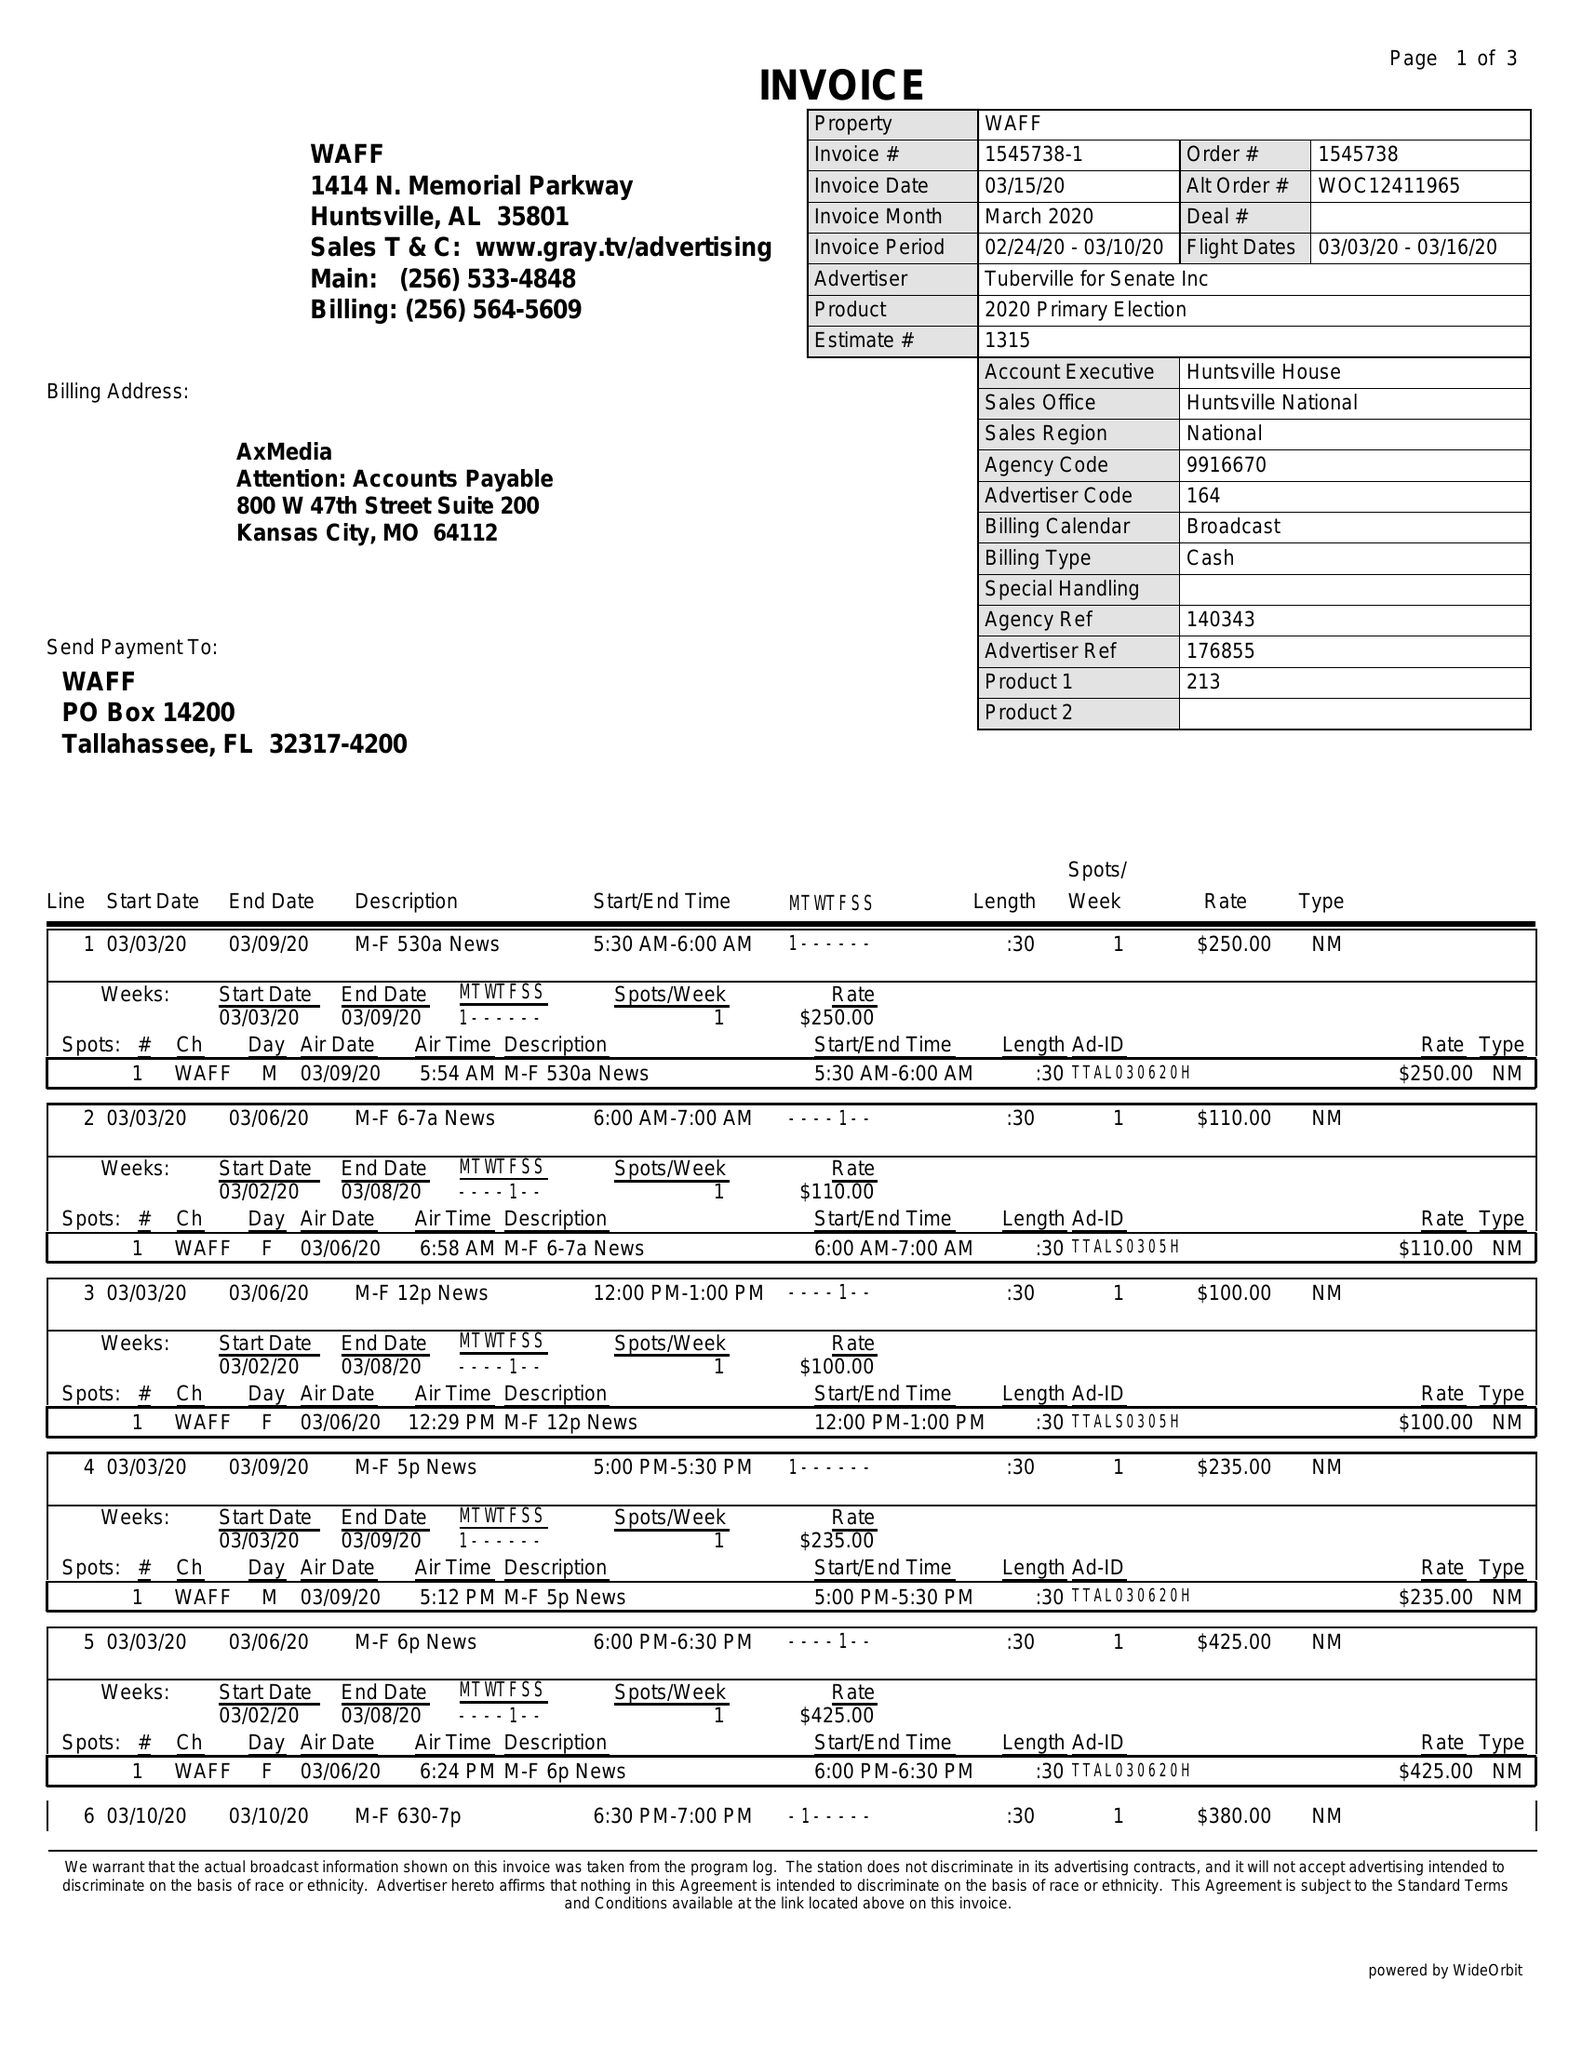What is the value for the flight_to?
Answer the question using a single word or phrase. 03/16/20 